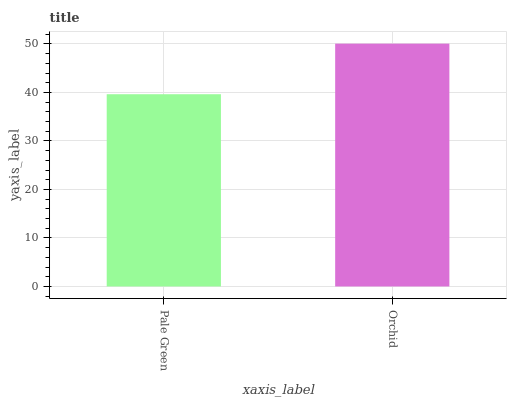Is Pale Green the minimum?
Answer yes or no. Yes. Is Orchid the maximum?
Answer yes or no. Yes. Is Orchid the minimum?
Answer yes or no. No. Is Orchid greater than Pale Green?
Answer yes or no. Yes. Is Pale Green less than Orchid?
Answer yes or no. Yes. Is Pale Green greater than Orchid?
Answer yes or no. No. Is Orchid less than Pale Green?
Answer yes or no. No. Is Orchid the high median?
Answer yes or no. Yes. Is Pale Green the low median?
Answer yes or no. Yes. Is Pale Green the high median?
Answer yes or no. No. Is Orchid the low median?
Answer yes or no. No. 